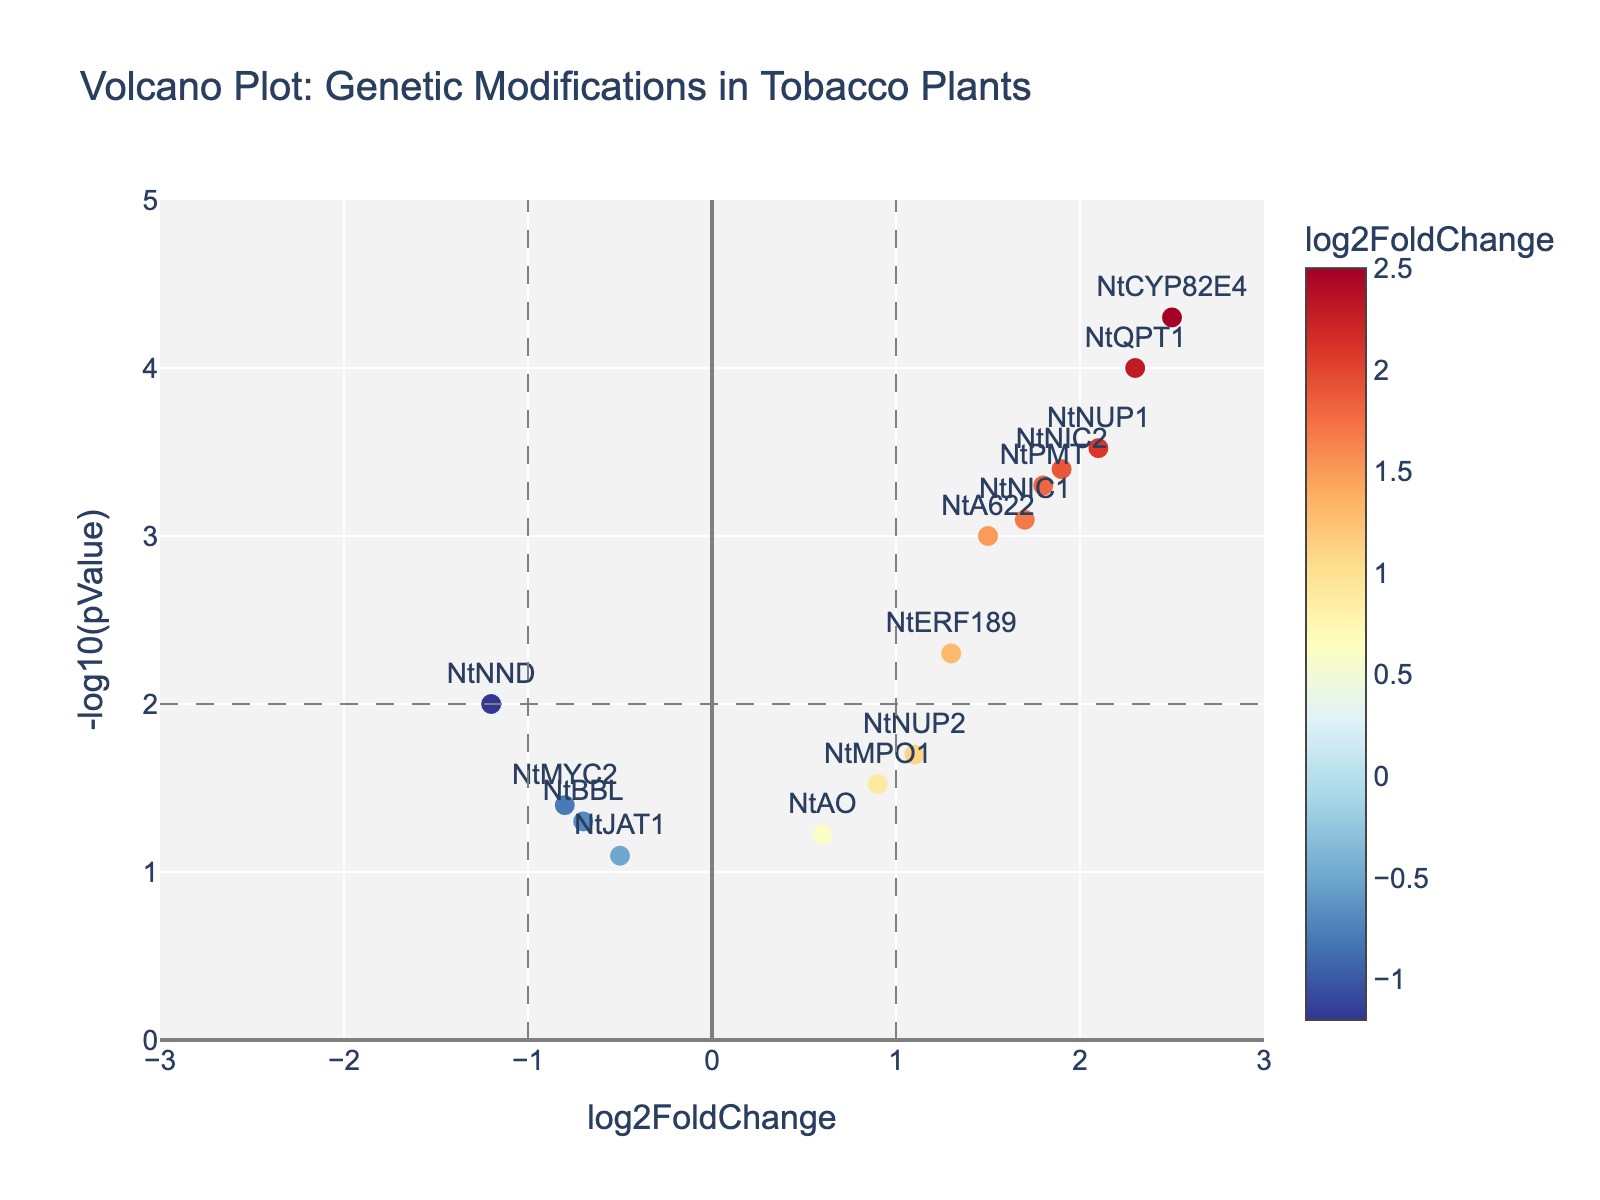What is the title of the plot? The title is typically displayed at the top of the plot. In this case, it is labeled as "Volcano Plot: Genetic Modifications in Tobacco Plants".
Answer: "Volcano Plot: Genetic Modifications in Tobacco Plants" How many genes have a positive log2FoldChange? By looking at the scatter plot, you can count the data points where the log2FoldChange is greater than zero. Those genes are located on the right side of the vertical axis representing the log2FoldChange of zero.
Answer: 10 Which gene has the highest log2FoldChange? The gene with the highest log2FoldChange is found at the farthest right on the x-axis. By inspecting the plot, NtCYP82E4 has the highest value in this regard.
Answer: NtCYP82E4 What is the log2FoldChange value for the gene NtPMT? To find this, locate the gene NtPMT on the plot, and check its position on the x-axis. It appears at log2FoldChange value close to 1.8.
Answer: 1.8 How does the p-value of NtQPT1 compare to that of NtCYP82E4? Both genes are located at the top of the plot, indicating very high significance. By comparing the y-axis values, NtCYP82E4 is higher, meaning it has a lower p-value compared to NtQPT1.
Answer: NtCYP82E4 has a lower p-value How many genes are below the p-value threshold of 0.01? The threshold for p-value 0.01 corresponds to -log10(pValue) = 2. Count the number of data points above y=2 on the plot. 7 genes meet this condition.
Answer: 7 What is the range of the y-axis? The y-axis is labeled as "-log10(pValue)" and ranges from 0 to 5.
Answer: 0 to 5 Which gene has the lowest p-value? The gene with the highest -log10(pValue) on the y-axis will have the lowest actual p-value. In this case, it is NtCYP82E4.
Answer: NtCYP82E4 What is the average log2FoldChange of genes with p-values less than 0.01? Calculate the average log2FoldChange of genes with -log10(pValue) above 2. These genes are NtCYP82E4, NtQPT1, NtNIC2, NtNUP1, NtPMT, NtNIC1, and NtA622. Their log2FoldChange values are 2.5, 2.3, 1.9, 2.1, 1.8, 1.7, and 1.5 respectively. The average is (2.5 + 2.3 + 1.9 + 2.1 + 1.8 + 1.7 + 1.5) / 7 = 1.97
Answer: 1.97 What is the color of the gene with the lowest log2FoldChange? The gene with the lowest log2FoldChange will be on the farthest left on the x-axis. NtNND has the lowest log2FoldChange and the color corresponding to this point is part of the RdYlBu_r colorscale.
Answer: Blue 